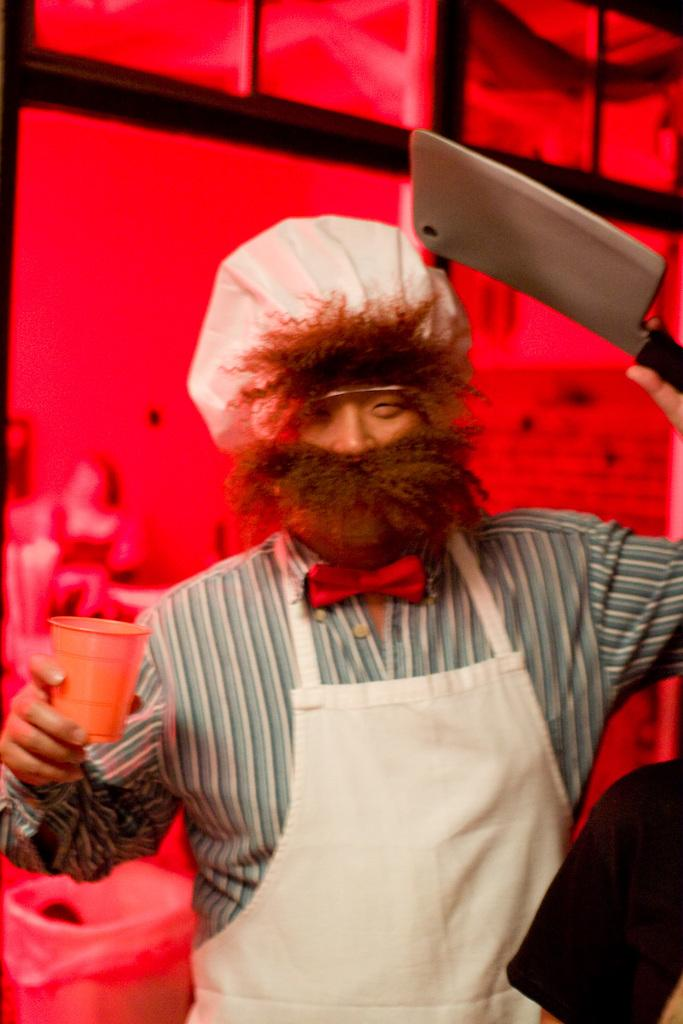What is the person in the image holding? The person is holding a glass and a knife. What might the person be doing with the glass and knife? The person might be preparing food or drinks. What can be seen in the background of the image? There is a dustbin and a photo frame on the wall in the background. What is the color of the background in the image? The background color is red. What type of yam is being served on the plate in the image? There is no plate or yam present in the image. How many cakes are visible on the table in the image? There are no cakes visible in the image. 